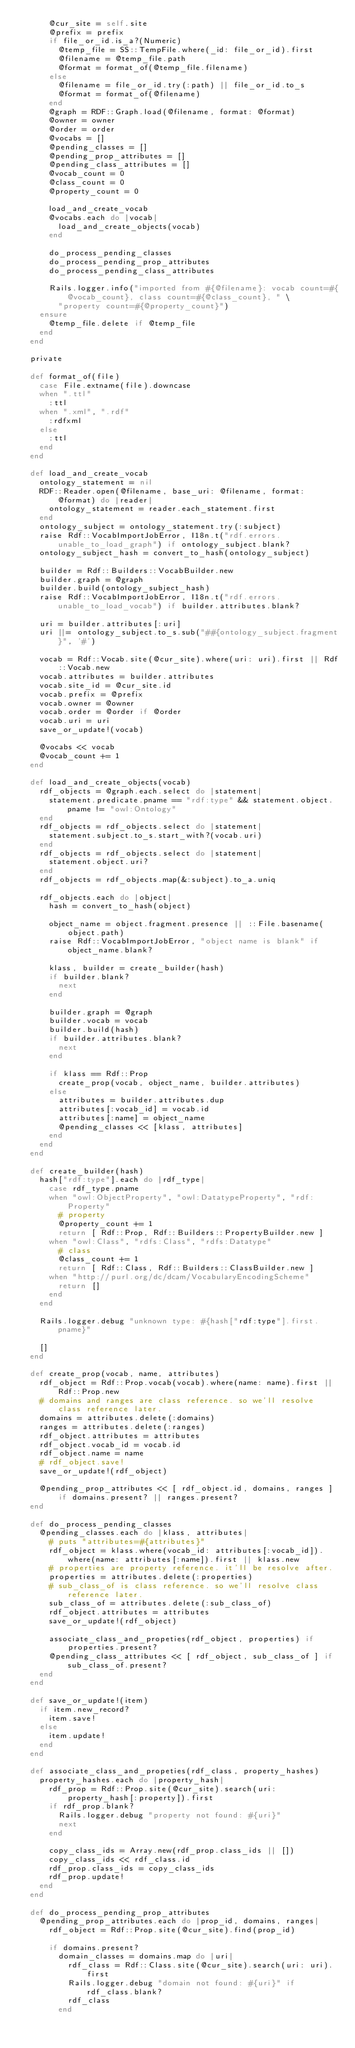<code> <loc_0><loc_0><loc_500><loc_500><_Ruby_>      @cur_site = self.site
      @prefix = prefix
      if file_or_id.is_a?(Numeric)
        @temp_file = SS::TempFile.where(_id: file_or_id).first
        @filename = @temp_file.path
        @format = format_of(@temp_file.filename)
      else
        @filename = file_or_id.try(:path) || file_or_id.to_s
        @format = format_of(@filename)
      end
      @graph = RDF::Graph.load(@filename, format: @format)
      @owner = owner
      @order = order
      @vocabs = []
      @pending_classes = []
      @pending_prop_attributes = []
      @pending_class_attributes = []
      @vocab_count = 0
      @class_count = 0
      @property_count = 0

      load_and_create_vocab
      @vocabs.each do |vocab|
        load_and_create_objects(vocab)
      end

      do_process_pending_classes
      do_process_pending_prop_attributes
      do_process_pending_class_attributes

      Rails.logger.info("imported from #{@filename}: vocab count=#{@vocab_count}, class count=#{@class_count}, " \
        "property count=#{@property_count}")
    ensure
      @temp_file.delete if @temp_file
    end
  end

  private

  def format_of(file)
    case File.extname(file).downcase
    when ".ttl"
      :ttl
    when ".xml", ".rdf"
      :rdfxml
    else
      :ttl
    end
  end

  def load_and_create_vocab
    ontology_statement = nil
    RDF::Reader.open(@filename, base_uri: @filename, format: @format) do |reader|
      ontology_statement = reader.each_statement.first
    end
    ontology_subject = ontology_statement.try(:subject)
    raise Rdf::VocabImportJobError, I18n.t("rdf.errors.unable_to_load_graph") if ontology_subject.blank?
    ontology_subject_hash = convert_to_hash(ontology_subject)

    builder = Rdf::Builders::VocabBuilder.new
    builder.graph = @graph
    builder.build(ontology_subject_hash)
    raise Rdf::VocabImportJobError, I18n.t("rdf.errors.unable_to_load_vocab") if builder.attributes.blank?

    uri = builder.attributes[:uri]
    uri ||= ontology_subject.to_s.sub("##{ontology_subject.fragment}", '#')

    vocab = Rdf::Vocab.site(@cur_site).where(uri: uri).first || Rdf::Vocab.new
    vocab.attributes = builder.attributes
    vocab.site_id = @cur_site.id
    vocab.prefix = @prefix
    vocab.owner = @owner
    vocab.order = @order if @order
    vocab.uri = uri
    save_or_update!(vocab)

    @vocabs << vocab
    @vocab_count += 1
  end

  def load_and_create_objects(vocab)
    rdf_objects = @graph.each.select do |statement|
      statement.predicate.pname == "rdf:type" && statement.object.pname != "owl:Ontology"
    end
    rdf_objects = rdf_objects.select do |statement|
      statement.subject.to_s.start_with?(vocab.uri)
    end
    rdf_objects = rdf_objects.select do |statement|
      statement.object.uri?
    end
    rdf_objects = rdf_objects.map(&:subject).to_a.uniq

    rdf_objects.each do |object|
      hash = convert_to_hash(object)

      object_name = object.fragment.presence || ::File.basename(object.path)
      raise Rdf::VocabImportJobError, "object name is blank" if object_name.blank?

      klass, builder = create_builder(hash)
      if builder.blank?
        next
      end

      builder.graph = @graph
      builder.vocab = vocab
      builder.build(hash)
      if builder.attributes.blank?
        next
      end

      if klass == Rdf::Prop
        create_prop(vocab, object_name, builder.attributes)
      else
        attributes = builder.attributes.dup
        attributes[:vocab_id] = vocab.id
        attributes[:name] = object_name
        @pending_classes << [klass, attributes]
      end
    end
  end

  def create_builder(hash)
    hash["rdf:type"].each do |rdf_type|
      case rdf_type.pname
      when "owl:ObjectProperty", "owl:DatatypeProperty", "rdf:Property"
        # property
        @property_count += 1
        return [ Rdf::Prop, Rdf::Builders::PropertyBuilder.new ]
      when "owl:Class", "rdfs:Class", "rdfs:Datatype"
        # class
        @class_count += 1
        return [ Rdf::Class, Rdf::Builders::ClassBuilder.new ]
      when "http://purl.org/dc/dcam/VocabularyEncodingScheme"
        return []
      end
    end

    Rails.logger.debug "unknown type: #{hash["rdf:type"].first.pname}"

    []
  end

  def create_prop(vocab, name, attributes)
    rdf_object = Rdf::Prop.vocab(vocab).where(name: name).first || Rdf::Prop.new
    # domains and ranges are class reference. so we'll resolve class reference later.
    domains = attributes.delete(:domains)
    ranges = attributes.delete(:ranges)
    rdf_object.attributes = attributes
    rdf_object.vocab_id = vocab.id
    rdf_object.name = name
    # rdf_object.save!
    save_or_update!(rdf_object)

    @pending_prop_attributes << [ rdf_object.id, domains, ranges ] if domains.present? || ranges.present?
  end

  def do_process_pending_classes
    @pending_classes.each do |klass, attributes|
      # puts "attributes=#{attributes}"
      rdf_object = klass.where(vocab_id: attributes[:vocab_id]).where(name: attributes[:name]).first || klass.new
      # properties are property reference. it'll be resolve after.
      properties = attributes.delete(:properties)
      # sub_class_of is class reference. so we'll resolve class reference later.
      sub_class_of = attributes.delete(:sub_class_of)
      rdf_object.attributes = attributes
      save_or_update!(rdf_object)

      associate_class_and_propeties(rdf_object, properties) if properties.present?
      @pending_class_attributes << [ rdf_object, sub_class_of ] if sub_class_of.present?
    end
  end

  def save_or_update!(item)
    if item.new_record?
      item.save!
    else
      item.update!
    end
  end

  def associate_class_and_propeties(rdf_class, property_hashes)
    property_hashes.each do |property_hash|
      rdf_prop = Rdf::Prop.site(@cur_site).search(uri: property_hash[:property]).first
      if rdf_prop.blank?
        Rails.logger.debug "property not found: #{uri}"
        next
      end

      copy_class_ids = Array.new(rdf_prop.class_ids || [])
      copy_class_ids << rdf_class.id
      rdf_prop.class_ids = copy_class_ids
      rdf_prop.update!
    end
  end

  def do_process_pending_prop_attributes
    @pending_prop_attributes.each do |prop_id, domains, ranges|
      rdf_object = Rdf::Prop.site(@cur_site).find(prop_id)

      if domains.present?
        domain_classes = domains.map do |uri|
          rdf_class = Rdf::Class.site(@cur_site).search(uri: uri).first
          Rails.logger.debug "domain not found: #{uri}" if rdf_class.blank?
          rdf_class
        end
</code> 